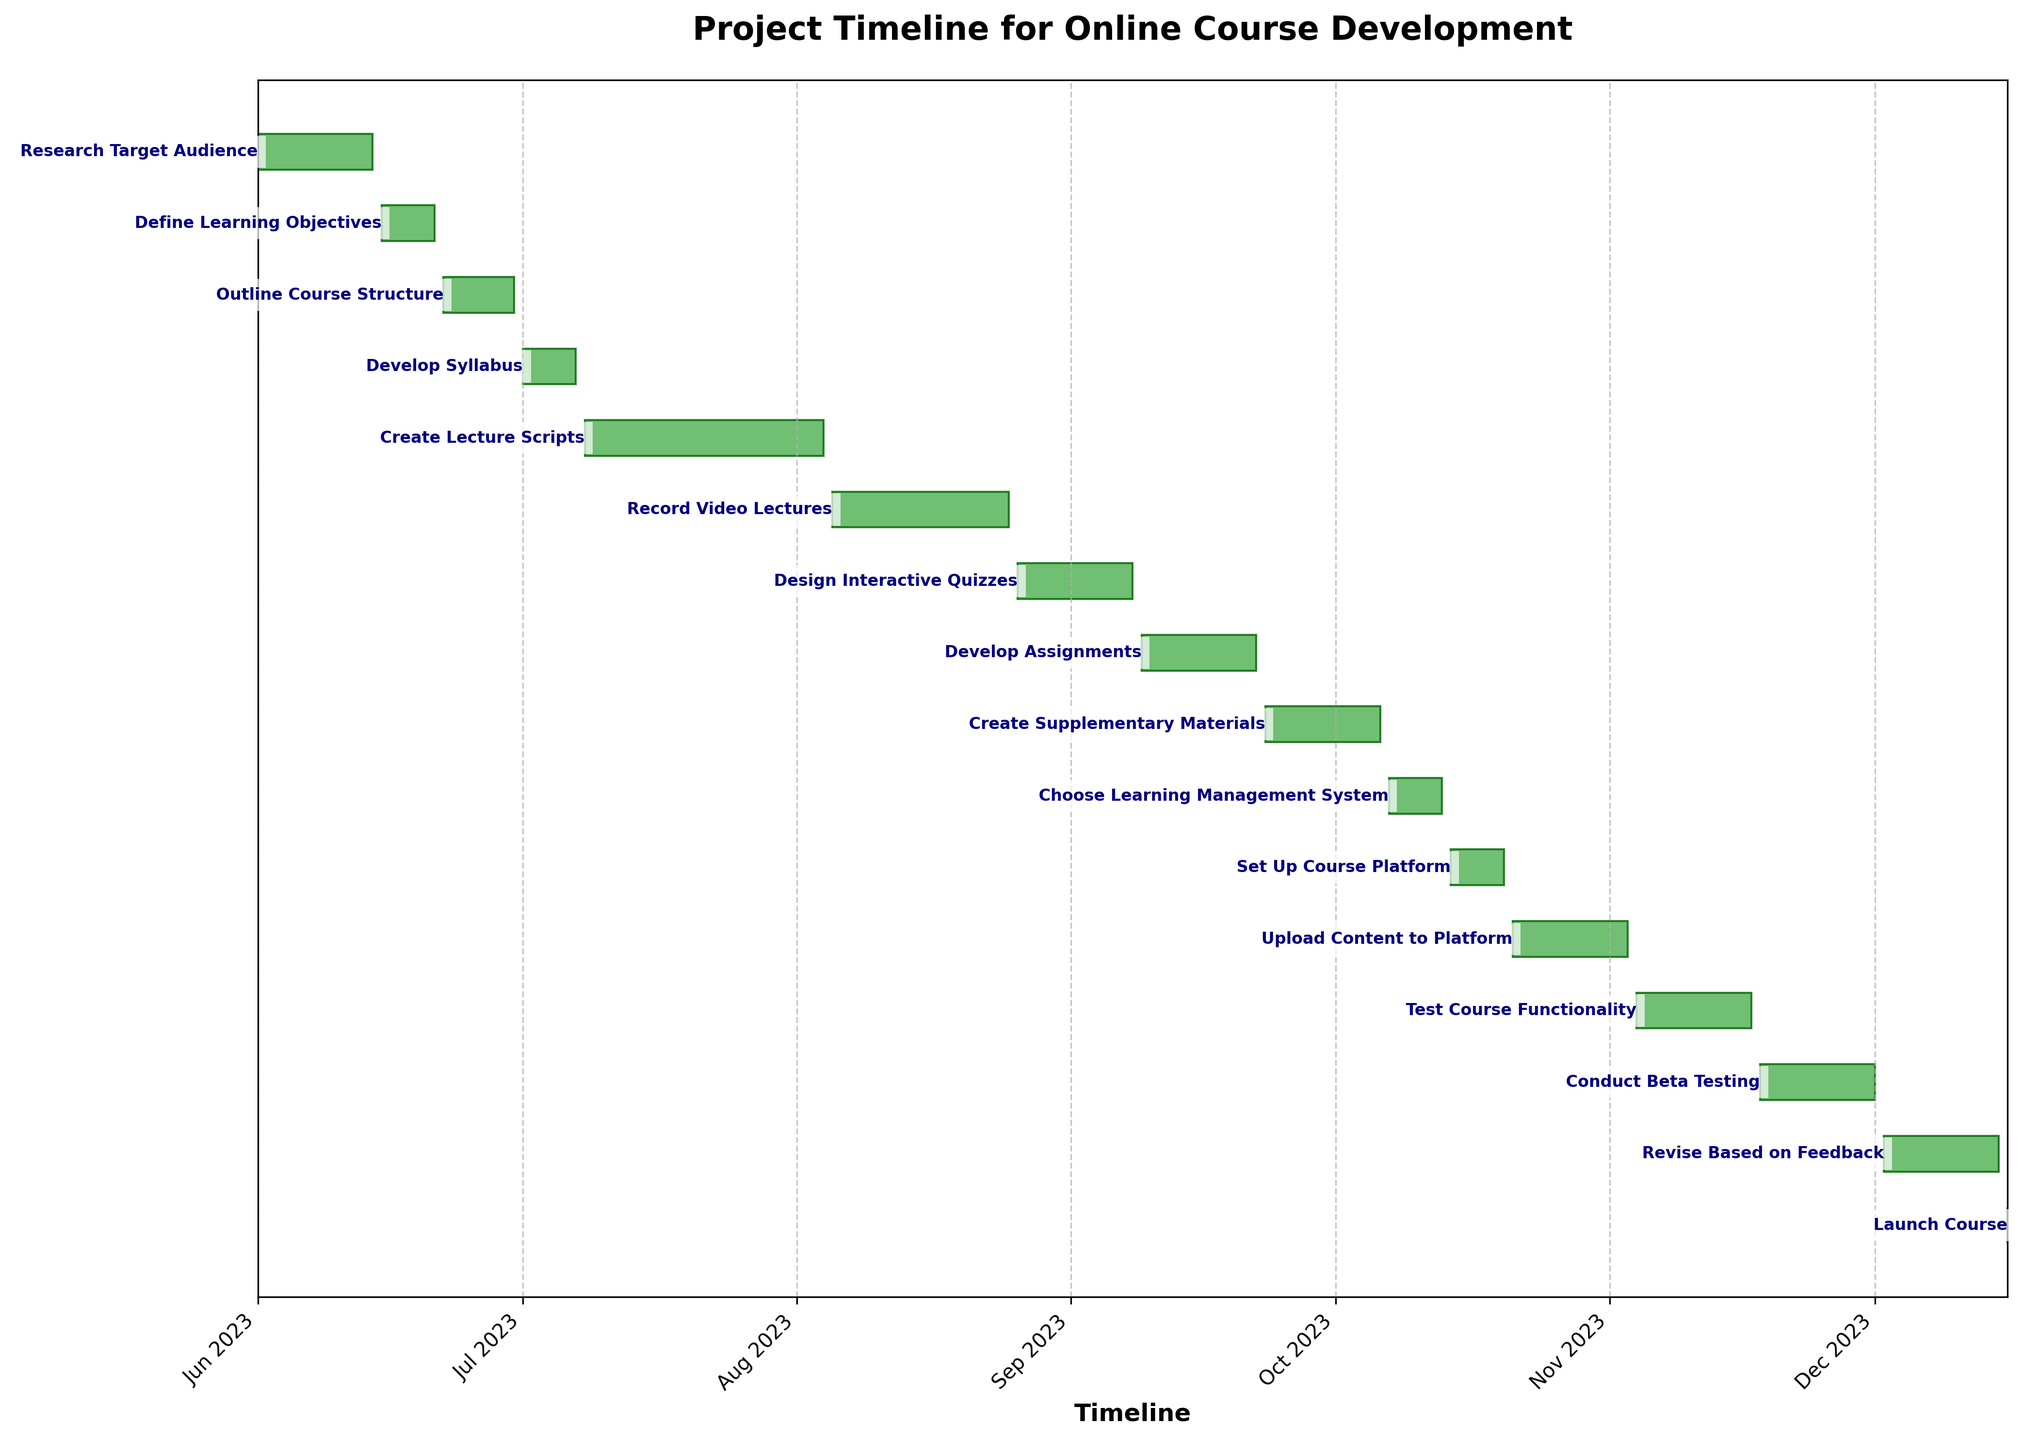What is the title of the chart? The title of the chart is typically found at the top, providing an overview of the content. In this chart, it is "Project Timeline for Online Course Development".
Answer: Project Timeline for Online Course Development Which task takes the longest to complete? To determine the longest task, observe the horizontal bars representing the task durations. The "Create Lecture Scripts" task has the longest bar.
Answer: Create Lecture Scripts How many tasks are scheduled to be completed in the month of October 2023? Look at the horizontal bars and identify the tasks with end dates within October 2023. These tasks are "Choose Learning Management System", "Set Up Course Platform", "Upload Content to Platform".
Answer: 3 Which phase directly follows "Research Target Audience"? The phases are typically ordered sequentially along the y-axis. The task immediately following "Research Target Audience" is "Define Learning Objectives".
Answer: Define Learning Objectives What is the combined duration of "Develop Syllabus" and "Record Video Lectures"? Find the individual durations of each task and add them together. "Develop Syllabus" spans 7 days, and "Record Video Lectures" spans 21 days. The combined duration is 7 + 21.
Answer: 28 days Which task is scheduled to start on August 26, 2023? Identify the task with the start date of August 26, 2023. The task is "Design Interactive Quizzes".
Answer: Design Interactive Quizzes How many tasks are there in total? Count the total number of horizontal bars representing tasks. There are 16 tasks listed.
Answer: 16 When does the "Test Course Functionality" phase end? Look for the end date associated with the "Test Course Functionality" task. According to the chart, it ends on November 17, 2023.
Answer: November 17, 2023 Which task takes the shortest amount of time to complete? Identify the task with the shortest horizontal bar, which corresponds to the task with the shortest duration. The shortest task is "Launch Course" with a duration of 1 day.
Answer: Launch Course What is the difference in days between the start of "Create Lecture Scripts" and the end of "Revise Based on Feedback"? Calculate the difference between the start date of "Create Lecture Scripts" (July 8, 2023) and the end date of "Revise Based on Feedback" (December 15, 2023). The difference is 160 days.
Answer: 160 days 